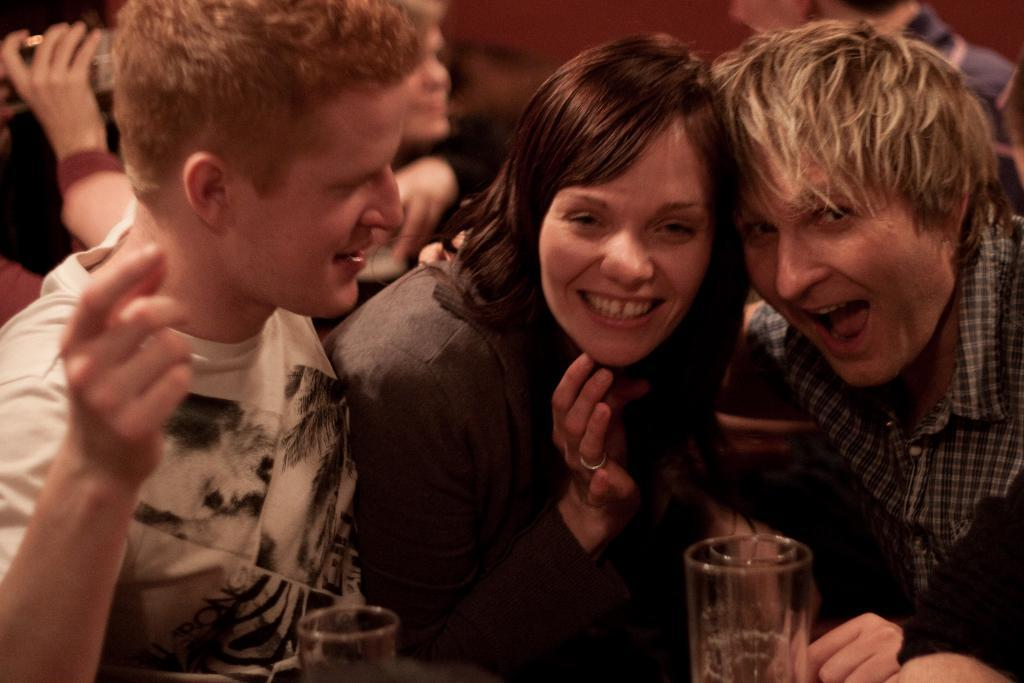How many people are in the image? There are men and a woman in the image, making a total of three people. What are the people in the image doing? The people in the image are smiling, which suggests they are happy or enjoying themselves. What objects can be seen in the image? There are glasses visible in the image. What type of silk fabric is draped over the woman's shoulder in the image? There is no silk fabric present in the image; the woman is not wearing any clothing or accessories that resemble silk. 